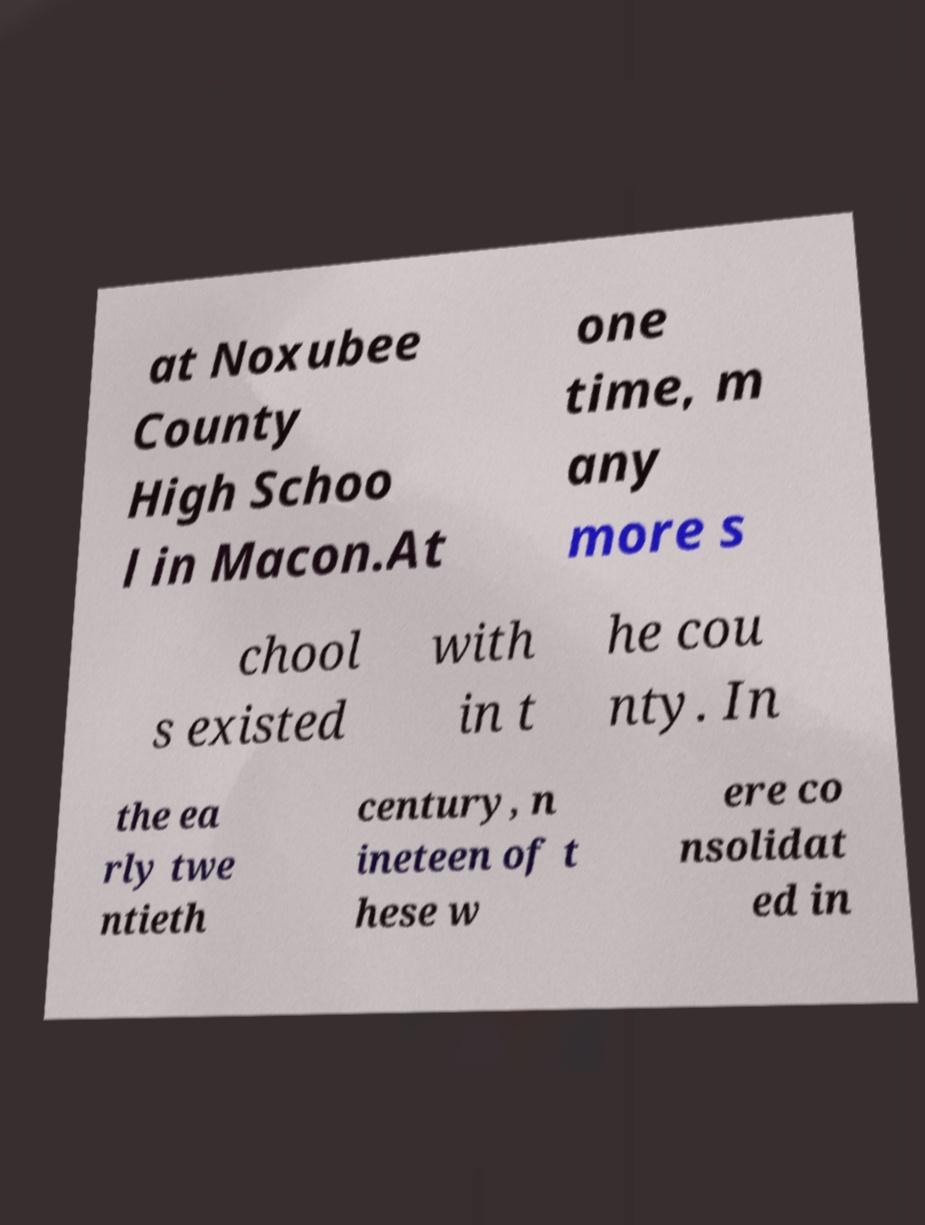Could you extract and type out the text from this image? at Noxubee County High Schoo l in Macon.At one time, m any more s chool s existed with in t he cou nty. In the ea rly twe ntieth century, n ineteen of t hese w ere co nsolidat ed in 